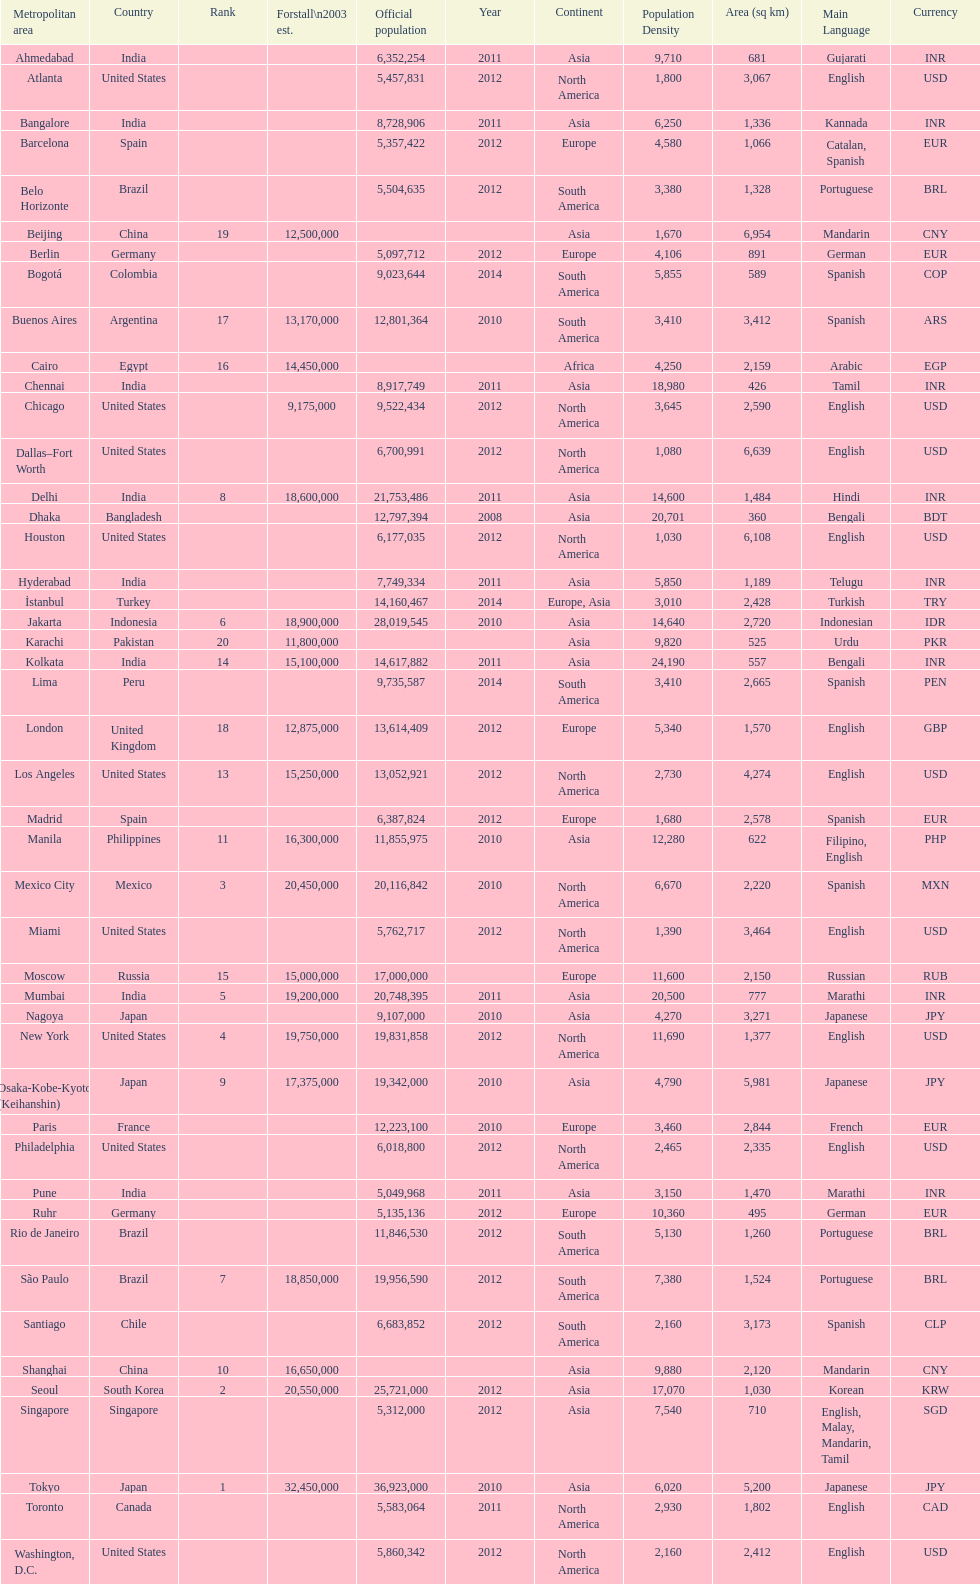Which population is listed before 5,357,422? 8,728,906. 